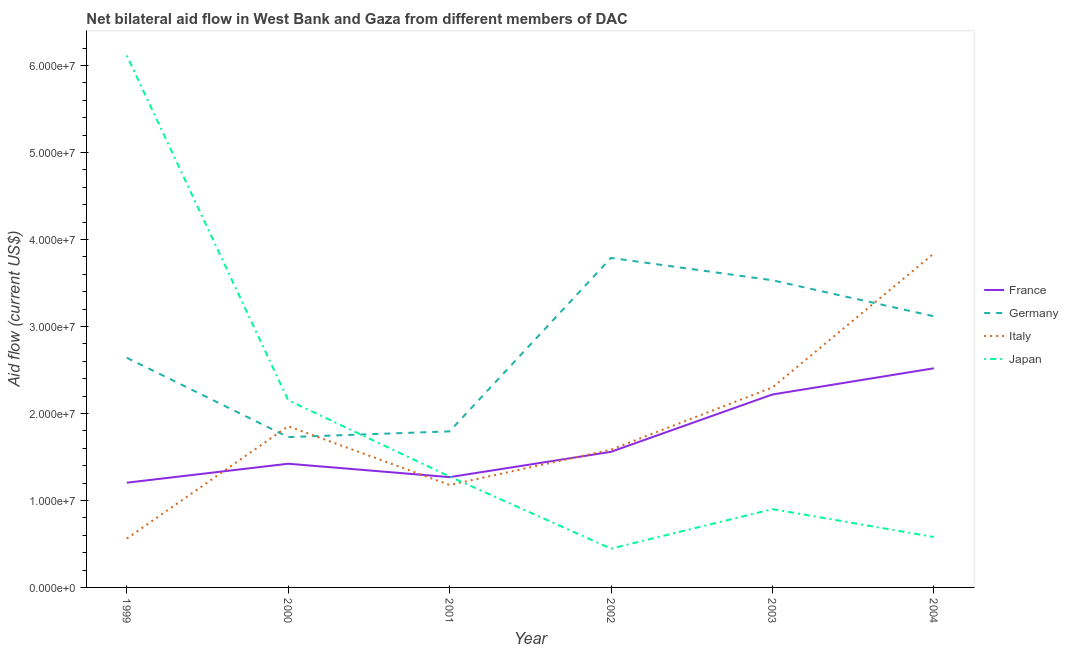How many different coloured lines are there?
Your answer should be compact. 4. What is the amount of aid given by france in 2000?
Offer a very short reply. 1.42e+07. Across all years, what is the maximum amount of aid given by france?
Offer a very short reply. 2.52e+07. Across all years, what is the minimum amount of aid given by germany?
Offer a very short reply. 1.73e+07. What is the total amount of aid given by italy in the graph?
Offer a terse response. 1.13e+08. What is the difference between the amount of aid given by japan in 2003 and that in 2004?
Provide a succinct answer. 3.20e+06. What is the difference between the amount of aid given by germany in 2000 and the amount of aid given by italy in 2003?
Keep it short and to the point. -5.71e+06. What is the average amount of aid given by france per year?
Make the answer very short. 1.70e+07. In the year 2002, what is the difference between the amount of aid given by germany and amount of aid given by italy?
Offer a very short reply. 2.20e+07. In how many years, is the amount of aid given by italy greater than 12000000 US$?
Your answer should be compact. 4. What is the ratio of the amount of aid given by italy in 1999 to that in 2000?
Give a very brief answer. 0.3. Is the amount of aid given by japan in 2000 less than that in 2002?
Offer a terse response. No. Is the difference between the amount of aid given by italy in 1999 and 2004 greater than the difference between the amount of aid given by japan in 1999 and 2004?
Your response must be concise. No. What is the difference between the highest and the second highest amount of aid given by italy?
Offer a terse response. 1.54e+07. What is the difference between the highest and the lowest amount of aid given by italy?
Your response must be concise. 3.28e+07. In how many years, is the amount of aid given by france greater than the average amount of aid given by france taken over all years?
Your answer should be compact. 2. What is the difference between two consecutive major ticks on the Y-axis?
Keep it short and to the point. 1.00e+07. Are the values on the major ticks of Y-axis written in scientific E-notation?
Provide a succinct answer. Yes. Does the graph contain grids?
Your response must be concise. No. How are the legend labels stacked?
Your response must be concise. Vertical. What is the title of the graph?
Your answer should be compact. Net bilateral aid flow in West Bank and Gaza from different members of DAC. What is the Aid flow (current US$) of France in 1999?
Ensure brevity in your answer.  1.20e+07. What is the Aid flow (current US$) of Germany in 1999?
Give a very brief answer. 2.64e+07. What is the Aid flow (current US$) of Italy in 1999?
Keep it short and to the point. 5.61e+06. What is the Aid flow (current US$) of Japan in 1999?
Keep it short and to the point. 6.12e+07. What is the Aid flow (current US$) in France in 2000?
Keep it short and to the point. 1.42e+07. What is the Aid flow (current US$) of Germany in 2000?
Provide a short and direct response. 1.73e+07. What is the Aid flow (current US$) of Italy in 2000?
Give a very brief answer. 1.85e+07. What is the Aid flow (current US$) in Japan in 2000?
Give a very brief answer. 2.15e+07. What is the Aid flow (current US$) of France in 2001?
Make the answer very short. 1.27e+07. What is the Aid flow (current US$) in Germany in 2001?
Offer a terse response. 1.79e+07. What is the Aid flow (current US$) in Italy in 2001?
Ensure brevity in your answer.  1.18e+07. What is the Aid flow (current US$) in Japan in 2001?
Your answer should be compact. 1.28e+07. What is the Aid flow (current US$) in France in 2002?
Your answer should be compact. 1.56e+07. What is the Aid flow (current US$) in Germany in 2002?
Make the answer very short. 3.79e+07. What is the Aid flow (current US$) in Italy in 2002?
Your response must be concise. 1.58e+07. What is the Aid flow (current US$) in Japan in 2002?
Your answer should be very brief. 4.46e+06. What is the Aid flow (current US$) of France in 2003?
Your answer should be compact. 2.22e+07. What is the Aid flow (current US$) in Germany in 2003?
Ensure brevity in your answer.  3.53e+07. What is the Aid flow (current US$) in Italy in 2003?
Ensure brevity in your answer.  2.30e+07. What is the Aid flow (current US$) in Japan in 2003?
Give a very brief answer. 9.00e+06. What is the Aid flow (current US$) of France in 2004?
Give a very brief answer. 2.52e+07. What is the Aid flow (current US$) in Germany in 2004?
Make the answer very short. 3.12e+07. What is the Aid flow (current US$) in Italy in 2004?
Ensure brevity in your answer.  3.84e+07. What is the Aid flow (current US$) of Japan in 2004?
Keep it short and to the point. 5.80e+06. Across all years, what is the maximum Aid flow (current US$) in France?
Provide a succinct answer. 2.52e+07. Across all years, what is the maximum Aid flow (current US$) of Germany?
Provide a short and direct response. 3.79e+07. Across all years, what is the maximum Aid flow (current US$) of Italy?
Your answer should be very brief. 3.84e+07. Across all years, what is the maximum Aid flow (current US$) of Japan?
Offer a very short reply. 6.12e+07. Across all years, what is the minimum Aid flow (current US$) in France?
Make the answer very short. 1.20e+07. Across all years, what is the minimum Aid flow (current US$) of Germany?
Make the answer very short. 1.73e+07. Across all years, what is the minimum Aid flow (current US$) of Italy?
Keep it short and to the point. 5.61e+06. Across all years, what is the minimum Aid flow (current US$) in Japan?
Your response must be concise. 4.46e+06. What is the total Aid flow (current US$) in France in the graph?
Your response must be concise. 1.02e+08. What is the total Aid flow (current US$) in Germany in the graph?
Offer a terse response. 1.66e+08. What is the total Aid flow (current US$) in Italy in the graph?
Your response must be concise. 1.13e+08. What is the total Aid flow (current US$) of Japan in the graph?
Offer a very short reply. 1.15e+08. What is the difference between the Aid flow (current US$) of France in 1999 and that in 2000?
Keep it short and to the point. -2.18e+06. What is the difference between the Aid flow (current US$) in Germany in 1999 and that in 2000?
Your answer should be compact. 9.12e+06. What is the difference between the Aid flow (current US$) in Italy in 1999 and that in 2000?
Offer a terse response. -1.29e+07. What is the difference between the Aid flow (current US$) of Japan in 1999 and that in 2000?
Provide a short and direct response. 3.96e+07. What is the difference between the Aid flow (current US$) of France in 1999 and that in 2001?
Your response must be concise. -6.40e+05. What is the difference between the Aid flow (current US$) of Germany in 1999 and that in 2001?
Give a very brief answer. 8.46e+06. What is the difference between the Aid flow (current US$) of Italy in 1999 and that in 2001?
Offer a terse response. -6.17e+06. What is the difference between the Aid flow (current US$) of Japan in 1999 and that in 2001?
Ensure brevity in your answer.  4.84e+07. What is the difference between the Aid flow (current US$) in France in 1999 and that in 2002?
Offer a very short reply. -3.55e+06. What is the difference between the Aid flow (current US$) in Germany in 1999 and that in 2002?
Provide a succinct answer. -1.15e+07. What is the difference between the Aid flow (current US$) of Italy in 1999 and that in 2002?
Give a very brief answer. -1.02e+07. What is the difference between the Aid flow (current US$) in Japan in 1999 and that in 2002?
Your response must be concise. 5.67e+07. What is the difference between the Aid flow (current US$) of France in 1999 and that in 2003?
Your answer should be compact. -1.01e+07. What is the difference between the Aid flow (current US$) of Germany in 1999 and that in 2003?
Provide a short and direct response. -8.91e+06. What is the difference between the Aid flow (current US$) in Italy in 1999 and that in 2003?
Offer a very short reply. -1.74e+07. What is the difference between the Aid flow (current US$) in Japan in 1999 and that in 2003?
Your answer should be compact. 5.22e+07. What is the difference between the Aid flow (current US$) in France in 1999 and that in 2004?
Your answer should be compact. -1.32e+07. What is the difference between the Aid flow (current US$) in Germany in 1999 and that in 2004?
Make the answer very short. -4.77e+06. What is the difference between the Aid flow (current US$) in Italy in 1999 and that in 2004?
Give a very brief answer. -3.28e+07. What is the difference between the Aid flow (current US$) in Japan in 1999 and that in 2004?
Ensure brevity in your answer.  5.54e+07. What is the difference between the Aid flow (current US$) of France in 2000 and that in 2001?
Give a very brief answer. 1.54e+06. What is the difference between the Aid flow (current US$) of Germany in 2000 and that in 2001?
Provide a succinct answer. -6.60e+05. What is the difference between the Aid flow (current US$) of Italy in 2000 and that in 2001?
Provide a short and direct response. 6.75e+06. What is the difference between the Aid flow (current US$) in Japan in 2000 and that in 2001?
Provide a short and direct response. 8.77e+06. What is the difference between the Aid flow (current US$) in France in 2000 and that in 2002?
Provide a short and direct response. -1.37e+06. What is the difference between the Aid flow (current US$) in Germany in 2000 and that in 2002?
Keep it short and to the point. -2.06e+07. What is the difference between the Aid flow (current US$) of Italy in 2000 and that in 2002?
Make the answer very short. 2.69e+06. What is the difference between the Aid flow (current US$) of Japan in 2000 and that in 2002?
Your answer should be compact. 1.71e+07. What is the difference between the Aid flow (current US$) in France in 2000 and that in 2003?
Offer a terse response. -7.96e+06. What is the difference between the Aid flow (current US$) of Germany in 2000 and that in 2003?
Give a very brief answer. -1.80e+07. What is the difference between the Aid flow (current US$) of Italy in 2000 and that in 2003?
Offer a terse response. -4.46e+06. What is the difference between the Aid flow (current US$) in Japan in 2000 and that in 2003?
Ensure brevity in your answer.  1.25e+07. What is the difference between the Aid flow (current US$) in France in 2000 and that in 2004?
Provide a short and direct response. -1.10e+07. What is the difference between the Aid flow (current US$) of Germany in 2000 and that in 2004?
Make the answer very short. -1.39e+07. What is the difference between the Aid flow (current US$) of Italy in 2000 and that in 2004?
Keep it short and to the point. -1.99e+07. What is the difference between the Aid flow (current US$) in Japan in 2000 and that in 2004?
Keep it short and to the point. 1.57e+07. What is the difference between the Aid flow (current US$) of France in 2001 and that in 2002?
Offer a terse response. -2.91e+06. What is the difference between the Aid flow (current US$) of Germany in 2001 and that in 2002?
Your answer should be compact. -1.99e+07. What is the difference between the Aid flow (current US$) of Italy in 2001 and that in 2002?
Give a very brief answer. -4.06e+06. What is the difference between the Aid flow (current US$) of Japan in 2001 and that in 2002?
Your answer should be very brief. 8.29e+06. What is the difference between the Aid flow (current US$) in France in 2001 and that in 2003?
Your answer should be very brief. -9.50e+06. What is the difference between the Aid flow (current US$) of Germany in 2001 and that in 2003?
Your response must be concise. -1.74e+07. What is the difference between the Aid flow (current US$) in Italy in 2001 and that in 2003?
Your answer should be very brief. -1.12e+07. What is the difference between the Aid flow (current US$) in Japan in 2001 and that in 2003?
Make the answer very short. 3.75e+06. What is the difference between the Aid flow (current US$) of France in 2001 and that in 2004?
Your response must be concise. -1.25e+07. What is the difference between the Aid flow (current US$) of Germany in 2001 and that in 2004?
Your answer should be very brief. -1.32e+07. What is the difference between the Aid flow (current US$) in Italy in 2001 and that in 2004?
Keep it short and to the point. -2.66e+07. What is the difference between the Aid flow (current US$) in Japan in 2001 and that in 2004?
Make the answer very short. 6.95e+06. What is the difference between the Aid flow (current US$) of France in 2002 and that in 2003?
Make the answer very short. -6.59e+06. What is the difference between the Aid flow (current US$) in Germany in 2002 and that in 2003?
Keep it short and to the point. 2.57e+06. What is the difference between the Aid flow (current US$) of Italy in 2002 and that in 2003?
Your response must be concise. -7.15e+06. What is the difference between the Aid flow (current US$) of Japan in 2002 and that in 2003?
Your answer should be very brief. -4.54e+06. What is the difference between the Aid flow (current US$) of France in 2002 and that in 2004?
Make the answer very short. -9.60e+06. What is the difference between the Aid flow (current US$) of Germany in 2002 and that in 2004?
Keep it short and to the point. 6.71e+06. What is the difference between the Aid flow (current US$) of Italy in 2002 and that in 2004?
Offer a terse response. -2.26e+07. What is the difference between the Aid flow (current US$) in Japan in 2002 and that in 2004?
Your response must be concise. -1.34e+06. What is the difference between the Aid flow (current US$) of France in 2003 and that in 2004?
Your response must be concise. -3.01e+06. What is the difference between the Aid flow (current US$) in Germany in 2003 and that in 2004?
Keep it short and to the point. 4.14e+06. What is the difference between the Aid flow (current US$) in Italy in 2003 and that in 2004?
Give a very brief answer. -1.54e+07. What is the difference between the Aid flow (current US$) of Japan in 2003 and that in 2004?
Your answer should be compact. 3.20e+06. What is the difference between the Aid flow (current US$) in France in 1999 and the Aid flow (current US$) in Germany in 2000?
Offer a terse response. -5.24e+06. What is the difference between the Aid flow (current US$) of France in 1999 and the Aid flow (current US$) of Italy in 2000?
Your answer should be very brief. -6.49e+06. What is the difference between the Aid flow (current US$) of France in 1999 and the Aid flow (current US$) of Japan in 2000?
Your response must be concise. -9.48e+06. What is the difference between the Aid flow (current US$) in Germany in 1999 and the Aid flow (current US$) in Italy in 2000?
Keep it short and to the point. 7.87e+06. What is the difference between the Aid flow (current US$) in Germany in 1999 and the Aid flow (current US$) in Japan in 2000?
Keep it short and to the point. 4.88e+06. What is the difference between the Aid flow (current US$) in Italy in 1999 and the Aid flow (current US$) in Japan in 2000?
Make the answer very short. -1.59e+07. What is the difference between the Aid flow (current US$) in France in 1999 and the Aid flow (current US$) in Germany in 2001?
Keep it short and to the point. -5.90e+06. What is the difference between the Aid flow (current US$) in France in 1999 and the Aid flow (current US$) in Japan in 2001?
Offer a terse response. -7.10e+05. What is the difference between the Aid flow (current US$) in Germany in 1999 and the Aid flow (current US$) in Italy in 2001?
Your answer should be very brief. 1.46e+07. What is the difference between the Aid flow (current US$) in Germany in 1999 and the Aid flow (current US$) in Japan in 2001?
Your response must be concise. 1.36e+07. What is the difference between the Aid flow (current US$) in Italy in 1999 and the Aid flow (current US$) in Japan in 2001?
Offer a very short reply. -7.14e+06. What is the difference between the Aid flow (current US$) of France in 1999 and the Aid flow (current US$) of Germany in 2002?
Provide a succinct answer. -2.58e+07. What is the difference between the Aid flow (current US$) of France in 1999 and the Aid flow (current US$) of Italy in 2002?
Provide a short and direct response. -3.80e+06. What is the difference between the Aid flow (current US$) of France in 1999 and the Aid flow (current US$) of Japan in 2002?
Ensure brevity in your answer.  7.58e+06. What is the difference between the Aid flow (current US$) of Germany in 1999 and the Aid flow (current US$) of Italy in 2002?
Ensure brevity in your answer.  1.06e+07. What is the difference between the Aid flow (current US$) of Germany in 1999 and the Aid flow (current US$) of Japan in 2002?
Offer a terse response. 2.19e+07. What is the difference between the Aid flow (current US$) in Italy in 1999 and the Aid flow (current US$) in Japan in 2002?
Keep it short and to the point. 1.15e+06. What is the difference between the Aid flow (current US$) in France in 1999 and the Aid flow (current US$) in Germany in 2003?
Make the answer very short. -2.33e+07. What is the difference between the Aid flow (current US$) in France in 1999 and the Aid flow (current US$) in Italy in 2003?
Your answer should be very brief. -1.10e+07. What is the difference between the Aid flow (current US$) in France in 1999 and the Aid flow (current US$) in Japan in 2003?
Your answer should be compact. 3.04e+06. What is the difference between the Aid flow (current US$) of Germany in 1999 and the Aid flow (current US$) of Italy in 2003?
Provide a succinct answer. 3.41e+06. What is the difference between the Aid flow (current US$) in Germany in 1999 and the Aid flow (current US$) in Japan in 2003?
Your response must be concise. 1.74e+07. What is the difference between the Aid flow (current US$) of Italy in 1999 and the Aid flow (current US$) of Japan in 2003?
Your answer should be very brief. -3.39e+06. What is the difference between the Aid flow (current US$) of France in 1999 and the Aid flow (current US$) of Germany in 2004?
Your response must be concise. -1.91e+07. What is the difference between the Aid flow (current US$) of France in 1999 and the Aid flow (current US$) of Italy in 2004?
Offer a very short reply. -2.64e+07. What is the difference between the Aid flow (current US$) of France in 1999 and the Aid flow (current US$) of Japan in 2004?
Give a very brief answer. 6.24e+06. What is the difference between the Aid flow (current US$) in Germany in 1999 and the Aid flow (current US$) in Italy in 2004?
Provide a short and direct response. -1.20e+07. What is the difference between the Aid flow (current US$) of Germany in 1999 and the Aid flow (current US$) of Japan in 2004?
Your answer should be compact. 2.06e+07. What is the difference between the Aid flow (current US$) in France in 2000 and the Aid flow (current US$) in Germany in 2001?
Your answer should be compact. -3.72e+06. What is the difference between the Aid flow (current US$) in France in 2000 and the Aid flow (current US$) in Italy in 2001?
Make the answer very short. 2.44e+06. What is the difference between the Aid flow (current US$) in France in 2000 and the Aid flow (current US$) in Japan in 2001?
Make the answer very short. 1.47e+06. What is the difference between the Aid flow (current US$) of Germany in 2000 and the Aid flow (current US$) of Italy in 2001?
Ensure brevity in your answer.  5.50e+06. What is the difference between the Aid flow (current US$) of Germany in 2000 and the Aid flow (current US$) of Japan in 2001?
Keep it short and to the point. 4.53e+06. What is the difference between the Aid flow (current US$) of Italy in 2000 and the Aid flow (current US$) of Japan in 2001?
Provide a succinct answer. 5.78e+06. What is the difference between the Aid flow (current US$) of France in 2000 and the Aid flow (current US$) of Germany in 2002?
Provide a succinct answer. -2.37e+07. What is the difference between the Aid flow (current US$) of France in 2000 and the Aid flow (current US$) of Italy in 2002?
Provide a succinct answer. -1.62e+06. What is the difference between the Aid flow (current US$) in France in 2000 and the Aid flow (current US$) in Japan in 2002?
Make the answer very short. 9.76e+06. What is the difference between the Aid flow (current US$) in Germany in 2000 and the Aid flow (current US$) in Italy in 2002?
Offer a terse response. 1.44e+06. What is the difference between the Aid flow (current US$) of Germany in 2000 and the Aid flow (current US$) of Japan in 2002?
Make the answer very short. 1.28e+07. What is the difference between the Aid flow (current US$) in Italy in 2000 and the Aid flow (current US$) in Japan in 2002?
Ensure brevity in your answer.  1.41e+07. What is the difference between the Aid flow (current US$) in France in 2000 and the Aid flow (current US$) in Germany in 2003?
Give a very brief answer. -2.11e+07. What is the difference between the Aid flow (current US$) in France in 2000 and the Aid flow (current US$) in Italy in 2003?
Keep it short and to the point. -8.77e+06. What is the difference between the Aid flow (current US$) in France in 2000 and the Aid flow (current US$) in Japan in 2003?
Your answer should be very brief. 5.22e+06. What is the difference between the Aid flow (current US$) in Germany in 2000 and the Aid flow (current US$) in Italy in 2003?
Provide a succinct answer. -5.71e+06. What is the difference between the Aid flow (current US$) of Germany in 2000 and the Aid flow (current US$) of Japan in 2003?
Your response must be concise. 8.28e+06. What is the difference between the Aid flow (current US$) in Italy in 2000 and the Aid flow (current US$) in Japan in 2003?
Your answer should be very brief. 9.53e+06. What is the difference between the Aid flow (current US$) in France in 2000 and the Aid flow (current US$) in Germany in 2004?
Make the answer very short. -1.70e+07. What is the difference between the Aid flow (current US$) of France in 2000 and the Aid flow (current US$) of Italy in 2004?
Your answer should be compact. -2.42e+07. What is the difference between the Aid flow (current US$) of France in 2000 and the Aid flow (current US$) of Japan in 2004?
Provide a succinct answer. 8.42e+06. What is the difference between the Aid flow (current US$) of Germany in 2000 and the Aid flow (current US$) of Italy in 2004?
Offer a terse response. -2.11e+07. What is the difference between the Aid flow (current US$) in Germany in 2000 and the Aid flow (current US$) in Japan in 2004?
Offer a terse response. 1.15e+07. What is the difference between the Aid flow (current US$) of Italy in 2000 and the Aid flow (current US$) of Japan in 2004?
Provide a succinct answer. 1.27e+07. What is the difference between the Aid flow (current US$) in France in 2001 and the Aid flow (current US$) in Germany in 2002?
Ensure brevity in your answer.  -2.52e+07. What is the difference between the Aid flow (current US$) of France in 2001 and the Aid flow (current US$) of Italy in 2002?
Ensure brevity in your answer.  -3.16e+06. What is the difference between the Aid flow (current US$) in France in 2001 and the Aid flow (current US$) in Japan in 2002?
Offer a terse response. 8.22e+06. What is the difference between the Aid flow (current US$) of Germany in 2001 and the Aid flow (current US$) of Italy in 2002?
Your answer should be compact. 2.10e+06. What is the difference between the Aid flow (current US$) of Germany in 2001 and the Aid flow (current US$) of Japan in 2002?
Your response must be concise. 1.35e+07. What is the difference between the Aid flow (current US$) of Italy in 2001 and the Aid flow (current US$) of Japan in 2002?
Offer a terse response. 7.32e+06. What is the difference between the Aid flow (current US$) in France in 2001 and the Aid flow (current US$) in Germany in 2003?
Your answer should be very brief. -2.26e+07. What is the difference between the Aid flow (current US$) in France in 2001 and the Aid flow (current US$) in Italy in 2003?
Your answer should be very brief. -1.03e+07. What is the difference between the Aid flow (current US$) in France in 2001 and the Aid flow (current US$) in Japan in 2003?
Ensure brevity in your answer.  3.68e+06. What is the difference between the Aid flow (current US$) in Germany in 2001 and the Aid flow (current US$) in Italy in 2003?
Make the answer very short. -5.05e+06. What is the difference between the Aid flow (current US$) of Germany in 2001 and the Aid flow (current US$) of Japan in 2003?
Your response must be concise. 8.94e+06. What is the difference between the Aid flow (current US$) of Italy in 2001 and the Aid flow (current US$) of Japan in 2003?
Ensure brevity in your answer.  2.78e+06. What is the difference between the Aid flow (current US$) of France in 2001 and the Aid flow (current US$) of Germany in 2004?
Keep it short and to the point. -1.85e+07. What is the difference between the Aid flow (current US$) of France in 2001 and the Aid flow (current US$) of Italy in 2004?
Keep it short and to the point. -2.57e+07. What is the difference between the Aid flow (current US$) of France in 2001 and the Aid flow (current US$) of Japan in 2004?
Make the answer very short. 6.88e+06. What is the difference between the Aid flow (current US$) of Germany in 2001 and the Aid flow (current US$) of Italy in 2004?
Provide a succinct answer. -2.04e+07. What is the difference between the Aid flow (current US$) in Germany in 2001 and the Aid flow (current US$) in Japan in 2004?
Ensure brevity in your answer.  1.21e+07. What is the difference between the Aid flow (current US$) in Italy in 2001 and the Aid flow (current US$) in Japan in 2004?
Keep it short and to the point. 5.98e+06. What is the difference between the Aid flow (current US$) in France in 2002 and the Aid flow (current US$) in Germany in 2003?
Provide a short and direct response. -1.97e+07. What is the difference between the Aid flow (current US$) in France in 2002 and the Aid flow (current US$) in Italy in 2003?
Offer a very short reply. -7.40e+06. What is the difference between the Aid flow (current US$) of France in 2002 and the Aid flow (current US$) of Japan in 2003?
Your answer should be compact. 6.59e+06. What is the difference between the Aid flow (current US$) of Germany in 2002 and the Aid flow (current US$) of Italy in 2003?
Ensure brevity in your answer.  1.49e+07. What is the difference between the Aid flow (current US$) of Germany in 2002 and the Aid flow (current US$) of Japan in 2003?
Your response must be concise. 2.89e+07. What is the difference between the Aid flow (current US$) of Italy in 2002 and the Aid flow (current US$) of Japan in 2003?
Your response must be concise. 6.84e+06. What is the difference between the Aid flow (current US$) in France in 2002 and the Aid flow (current US$) in Germany in 2004?
Your answer should be very brief. -1.56e+07. What is the difference between the Aid flow (current US$) of France in 2002 and the Aid flow (current US$) of Italy in 2004?
Provide a short and direct response. -2.28e+07. What is the difference between the Aid flow (current US$) in France in 2002 and the Aid flow (current US$) in Japan in 2004?
Give a very brief answer. 9.79e+06. What is the difference between the Aid flow (current US$) in Germany in 2002 and the Aid flow (current US$) in Italy in 2004?
Ensure brevity in your answer.  -5.10e+05. What is the difference between the Aid flow (current US$) in Germany in 2002 and the Aid flow (current US$) in Japan in 2004?
Make the answer very short. 3.21e+07. What is the difference between the Aid flow (current US$) in Italy in 2002 and the Aid flow (current US$) in Japan in 2004?
Keep it short and to the point. 1.00e+07. What is the difference between the Aid flow (current US$) of France in 2003 and the Aid flow (current US$) of Germany in 2004?
Make the answer very short. -8.99e+06. What is the difference between the Aid flow (current US$) of France in 2003 and the Aid flow (current US$) of Italy in 2004?
Your answer should be very brief. -1.62e+07. What is the difference between the Aid flow (current US$) in France in 2003 and the Aid flow (current US$) in Japan in 2004?
Give a very brief answer. 1.64e+07. What is the difference between the Aid flow (current US$) in Germany in 2003 and the Aid flow (current US$) in Italy in 2004?
Your answer should be compact. -3.08e+06. What is the difference between the Aid flow (current US$) of Germany in 2003 and the Aid flow (current US$) of Japan in 2004?
Keep it short and to the point. 2.95e+07. What is the difference between the Aid flow (current US$) in Italy in 2003 and the Aid flow (current US$) in Japan in 2004?
Provide a succinct answer. 1.72e+07. What is the average Aid flow (current US$) of France per year?
Your answer should be compact. 1.70e+07. What is the average Aid flow (current US$) in Germany per year?
Offer a very short reply. 2.77e+07. What is the average Aid flow (current US$) of Italy per year?
Ensure brevity in your answer.  1.89e+07. What is the average Aid flow (current US$) of Japan per year?
Give a very brief answer. 1.91e+07. In the year 1999, what is the difference between the Aid flow (current US$) of France and Aid flow (current US$) of Germany?
Provide a short and direct response. -1.44e+07. In the year 1999, what is the difference between the Aid flow (current US$) in France and Aid flow (current US$) in Italy?
Your answer should be very brief. 6.43e+06. In the year 1999, what is the difference between the Aid flow (current US$) in France and Aid flow (current US$) in Japan?
Give a very brief answer. -4.91e+07. In the year 1999, what is the difference between the Aid flow (current US$) in Germany and Aid flow (current US$) in Italy?
Your answer should be compact. 2.08e+07. In the year 1999, what is the difference between the Aid flow (current US$) of Germany and Aid flow (current US$) of Japan?
Your answer should be compact. -3.48e+07. In the year 1999, what is the difference between the Aid flow (current US$) in Italy and Aid flow (current US$) in Japan?
Your answer should be compact. -5.55e+07. In the year 2000, what is the difference between the Aid flow (current US$) of France and Aid flow (current US$) of Germany?
Offer a very short reply. -3.06e+06. In the year 2000, what is the difference between the Aid flow (current US$) of France and Aid flow (current US$) of Italy?
Ensure brevity in your answer.  -4.31e+06. In the year 2000, what is the difference between the Aid flow (current US$) of France and Aid flow (current US$) of Japan?
Offer a very short reply. -7.30e+06. In the year 2000, what is the difference between the Aid flow (current US$) of Germany and Aid flow (current US$) of Italy?
Keep it short and to the point. -1.25e+06. In the year 2000, what is the difference between the Aid flow (current US$) of Germany and Aid flow (current US$) of Japan?
Provide a succinct answer. -4.24e+06. In the year 2000, what is the difference between the Aid flow (current US$) of Italy and Aid flow (current US$) of Japan?
Offer a terse response. -2.99e+06. In the year 2001, what is the difference between the Aid flow (current US$) of France and Aid flow (current US$) of Germany?
Your answer should be compact. -5.26e+06. In the year 2001, what is the difference between the Aid flow (current US$) in France and Aid flow (current US$) in Italy?
Your response must be concise. 9.00e+05. In the year 2001, what is the difference between the Aid flow (current US$) of Germany and Aid flow (current US$) of Italy?
Provide a short and direct response. 6.16e+06. In the year 2001, what is the difference between the Aid flow (current US$) of Germany and Aid flow (current US$) of Japan?
Give a very brief answer. 5.19e+06. In the year 2001, what is the difference between the Aid flow (current US$) of Italy and Aid flow (current US$) of Japan?
Offer a terse response. -9.70e+05. In the year 2002, what is the difference between the Aid flow (current US$) in France and Aid flow (current US$) in Germany?
Your answer should be very brief. -2.23e+07. In the year 2002, what is the difference between the Aid flow (current US$) of France and Aid flow (current US$) of Japan?
Make the answer very short. 1.11e+07. In the year 2002, what is the difference between the Aid flow (current US$) of Germany and Aid flow (current US$) of Italy?
Offer a very short reply. 2.20e+07. In the year 2002, what is the difference between the Aid flow (current US$) in Germany and Aid flow (current US$) in Japan?
Provide a succinct answer. 3.34e+07. In the year 2002, what is the difference between the Aid flow (current US$) in Italy and Aid flow (current US$) in Japan?
Keep it short and to the point. 1.14e+07. In the year 2003, what is the difference between the Aid flow (current US$) in France and Aid flow (current US$) in Germany?
Keep it short and to the point. -1.31e+07. In the year 2003, what is the difference between the Aid flow (current US$) of France and Aid flow (current US$) of Italy?
Your answer should be very brief. -8.10e+05. In the year 2003, what is the difference between the Aid flow (current US$) of France and Aid flow (current US$) of Japan?
Ensure brevity in your answer.  1.32e+07. In the year 2003, what is the difference between the Aid flow (current US$) in Germany and Aid flow (current US$) in Italy?
Your response must be concise. 1.23e+07. In the year 2003, what is the difference between the Aid flow (current US$) in Germany and Aid flow (current US$) in Japan?
Provide a short and direct response. 2.63e+07. In the year 2003, what is the difference between the Aid flow (current US$) of Italy and Aid flow (current US$) of Japan?
Offer a terse response. 1.40e+07. In the year 2004, what is the difference between the Aid flow (current US$) of France and Aid flow (current US$) of Germany?
Ensure brevity in your answer.  -5.98e+06. In the year 2004, what is the difference between the Aid flow (current US$) of France and Aid flow (current US$) of Italy?
Offer a very short reply. -1.32e+07. In the year 2004, what is the difference between the Aid flow (current US$) in France and Aid flow (current US$) in Japan?
Give a very brief answer. 1.94e+07. In the year 2004, what is the difference between the Aid flow (current US$) of Germany and Aid flow (current US$) of Italy?
Keep it short and to the point. -7.22e+06. In the year 2004, what is the difference between the Aid flow (current US$) of Germany and Aid flow (current US$) of Japan?
Keep it short and to the point. 2.54e+07. In the year 2004, what is the difference between the Aid flow (current US$) of Italy and Aid flow (current US$) of Japan?
Your answer should be very brief. 3.26e+07. What is the ratio of the Aid flow (current US$) of France in 1999 to that in 2000?
Give a very brief answer. 0.85. What is the ratio of the Aid flow (current US$) in Germany in 1999 to that in 2000?
Offer a terse response. 1.53. What is the ratio of the Aid flow (current US$) in Italy in 1999 to that in 2000?
Provide a succinct answer. 0.3. What is the ratio of the Aid flow (current US$) in Japan in 1999 to that in 2000?
Your answer should be very brief. 2.84. What is the ratio of the Aid flow (current US$) in France in 1999 to that in 2001?
Give a very brief answer. 0.95. What is the ratio of the Aid flow (current US$) in Germany in 1999 to that in 2001?
Offer a very short reply. 1.47. What is the ratio of the Aid flow (current US$) of Italy in 1999 to that in 2001?
Provide a short and direct response. 0.48. What is the ratio of the Aid flow (current US$) in Japan in 1999 to that in 2001?
Make the answer very short. 4.8. What is the ratio of the Aid flow (current US$) of France in 1999 to that in 2002?
Ensure brevity in your answer.  0.77. What is the ratio of the Aid flow (current US$) in Germany in 1999 to that in 2002?
Your answer should be compact. 0.7. What is the ratio of the Aid flow (current US$) of Italy in 1999 to that in 2002?
Ensure brevity in your answer.  0.35. What is the ratio of the Aid flow (current US$) of Japan in 1999 to that in 2002?
Ensure brevity in your answer.  13.71. What is the ratio of the Aid flow (current US$) in France in 1999 to that in 2003?
Provide a succinct answer. 0.54. What is the ratio of the Aid flow (current US$) of Germany in 1999 to that in 2003?
Offer a very short reply. 0.75. What is the ratio of the Aid flow (current US$) of Italy in 1999 to that in 2003?
Make the answer very short. 0.24. What is the ratio of the Aid flow (current US$) of Japan in 1999 to that in 2003?
Provide a succinct answer. 6.79. What is the ratio of the Aid flow (current US$) of France in 1999 to that in 2004?
Make the answer very short. 0.48. What is the ratio of the Aid flow (current US$) in Germany in 1999 to that in 2004?
Your response must be concise. 0.85. What is the ratio of the Aid flow (current US$) in Italy in 1999 to that in 2004?
Your response must be concise. 0.15. What is the ratio of the Aid flow (current US$) of Japan in 1999 to that in 2004?
Make the answer very short. 10.54. What is the ratio of the Aid flow (current US$) of France in 2000 to that in 2001?
Ensure brevity in your answer.  1.12. What is the ratio of the Aid flow (current US$) of Germany in 2000 to that in 2001?
Keep it short and to the point. 0.96. What is the ratio of the Aid flow (current US$) in Italy in 2000 to that in 2001?
Your response must be concise. 1.57. What is the ratio of the Aid flow (current US$) of Japan in 2000 to that in 2001?
Provide a short and direct response. 1.69. What is the ratio of the Aid flow (current US$) of France in 2000 to that in 2002?
Provide a succinct answer. 0.91. What is the ratio of the Aid flow (current US$) in Germany in 2000 to that in 2002?
Keep it short and to the point. 0.46. What is the ratio of the Aid flow (current US$) in Italy in 2000 to that in 2002?
Make the answer very short. 1.17. What is the ratio of the Aid flow (current US$) in Japan in 2000 to that in 2002?
Offer a very short reply. 4.83. What is the ratio of the Aid flow (current US$) in France in 2000 to that in 2003?
Provide a succinct answer. 0.64. What is the ratio of the Aid flow (current US$) in Germany in 2000 to that in 2003?
Offer a very short reply. 0.49. What is the ratio of the Aid flow (current US$) of Italy in 2000 to that in 2003?
Your answer should be compact. 0.81. What is the ratio of the Aid flow (current US$) of Japan in 2000 to that in 2003?
Give a very brief answer. 2.39. What is the ratio of the Aid flow (current US$) of France in 2000 to that in 2004?
Your answer should be very brief. 0.56. What is the ratio of the Aid flow (current US$) in Germany in 2000 to that in 2004?
Ensure brevity in your answer.  0.55. What is the ratio of the Aid flow (current US$) of Italy in 2000 to that in 2004?
Make the answer very short. 0.48. What is the ratio of the Aid flow (current US$) in Japan in 2000 to that in 2004?
Provide a succinct answer. 3.71. What is the ratio of the Aid flow (current US$) in France in 2001 to that in 2002?
Give a very brief answer. 0.81. What is the ratio of the Aid flow (current US$) in Germany in 2001 to that in 2002?
Provide a succinct answer. 0.47. What is the ratio of the Aid flow (current US$) of Italy in 2001 to that in 2002?
Offer a terse response. 0.74. What is the ratio of the Aid flow (current US$) in Japan in 2001 to that in 2002?
Provide a short and direct response. 2.86. What is the ratio of the Aid flow (current US$) of France in 2001 to that in 2003?
Your answer should be very brief. 0.57. What is the ratio of the Aid flow (current US$) in Germany in 2001 to that in 2003?
Give a very brief answer. 0.51. What is the ratio of the Aid flow (current US$) in Italy in 2001 to that in 2003?
Offer a terse response. 0.51. What is the ratio of the Aid flow (current US$) in Japan in 2001 to that in 2003?
Your response must be concise. 1.42. What is the ratio of the Aid flow (current US$) in France in 2001 to that in 2004?
Keep it short and to the point. 0.5. What is the ratio of the Aid flow (current US$) in Germany in 2001 to that in 2004?
Offer a very short reply. 0.58. What is the ratio of the Aid flow (current US$) of Italy in 2001 to that in 2004?
Your answer should be very brief. 0.31. What is the ratio of the Aid flow (current US$) in Japan in 2001 to that in 2004?
Keep it short and to the point. 2.2. What is the ratio of the Aid flow (current US$) in France in 2002 to that in 2003?
Ensure brevity in your answer.  0.7. What is the ratio of the Aid flow (current US$) in Germany in 2002 to that in 2003?
Offer a very short reply. 1.07. What is the ratio of the Aid flow (current US$) in Italy in 2002 to that in 2003?
Keep it short and to the point. 0.69. What is the ratio of the Aid flow (current US$) of Japan in 2002 to that in 2003?
Ensure brevity in your answer.  0.5. What is the ratio of the Aid flow (current US$) of France in 2002 to that in 2004?
Keep it short and to the point. 0.62. What is the ratio of the Aid flow (current US$) in Germany in 2002 to that in 2004?
Offer a very short reply. 1.22. What is the ratio of the Aid flow (current US$) of Italy in 2002 to that in 2004?
Your answer should be compact. 0.41. What is the ratio of the Aid flow (current US$) of Japan in 2002 to that in 2004?
Provide a short and direct response. 0.77. What is the ratio of the Aid flow (current US$) in France in 2003 to that in 2004?
Keep it short and to the point. 0.88. What is the ratio of the Aid flow (current US$) in Germany in 2003 to that in 2004?
Keep it short and to the point. 1.13. What is the ratio of the Aid flow (current US$) in Italy in 2003 to that in 2004?
Your answer should be compact. 0.6. What is the ratio of the Aid flow (current US$) in Japan in 2003 to that in 2004?
Keep it short and to the point. 1.55. What is the difference between the highest and the second highest Aid flow (current US$) of France?
Keep it short and to the point. 3.01e+06. What is the difference between the highest and the second highest Aid flow (current US$) in Germany?
Ensure brevity in your answer.  2.57e+06. What is the difference between the highest and the second highest Aid flow (current US$) of Italy?
Your response must be concise. 1.54e+07. What is the difference between the highest and the second highest Aid flow (current US$) of Japan?
Your answer should be very brief. 3.96e+07. What is the difference between the highest and the lowest Aid flow (current US$) in France?
Your answer should be compact. 1.32e+07. What is the difference between the highest and the lowest Aid flow (current US$) of Germany?
Your answer should be very brief. 2.06e+07. What is the difference between the highest and the lowest Aid flow (current US$) of Italy?
Your answer should be very brief. 3.28e+07. What is the difference between the highest and the lowest Aid flow (current US$) in Japan?
Make the answer very short. 5.67e+07. 